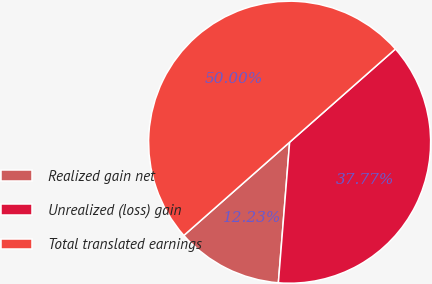Convert chart to OTSL. <chart><loc_0><loc_0><loc_500><loc_500><pie_chart><fcel>Realized gain net<fcel>Unrealized (loss) gain<fcel>Total translated earnings<nl><fcel>12.23%<fcel>37.77%<fcel>50.0%<nl></chart> 